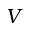Convert formula to latex. <formula><loc_0><loc_0><loc_500><loc_500>V</formula> 